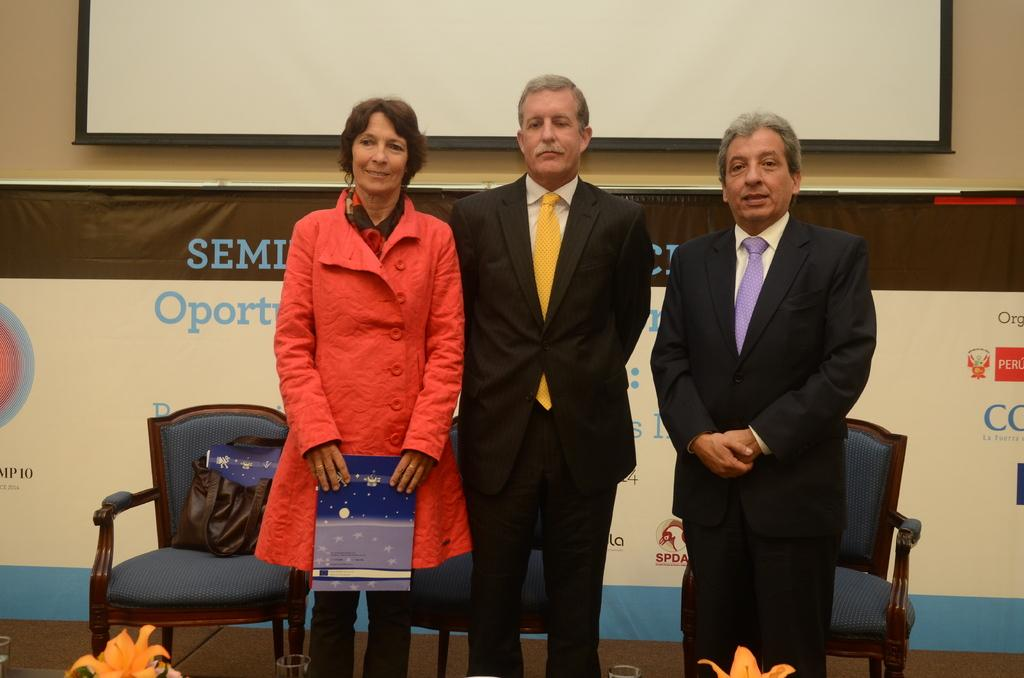How many people are present in the image? There are three people standing in the image. What is on the chair in the image? There is a bag on a chair in the image. What can be seen at the back side of the image? There is a banner and a screen at the back side of the image. Can you see a squirrel leading the group of people in the image? There is no squirrel present in the image, and the people are not being led by any animal. 